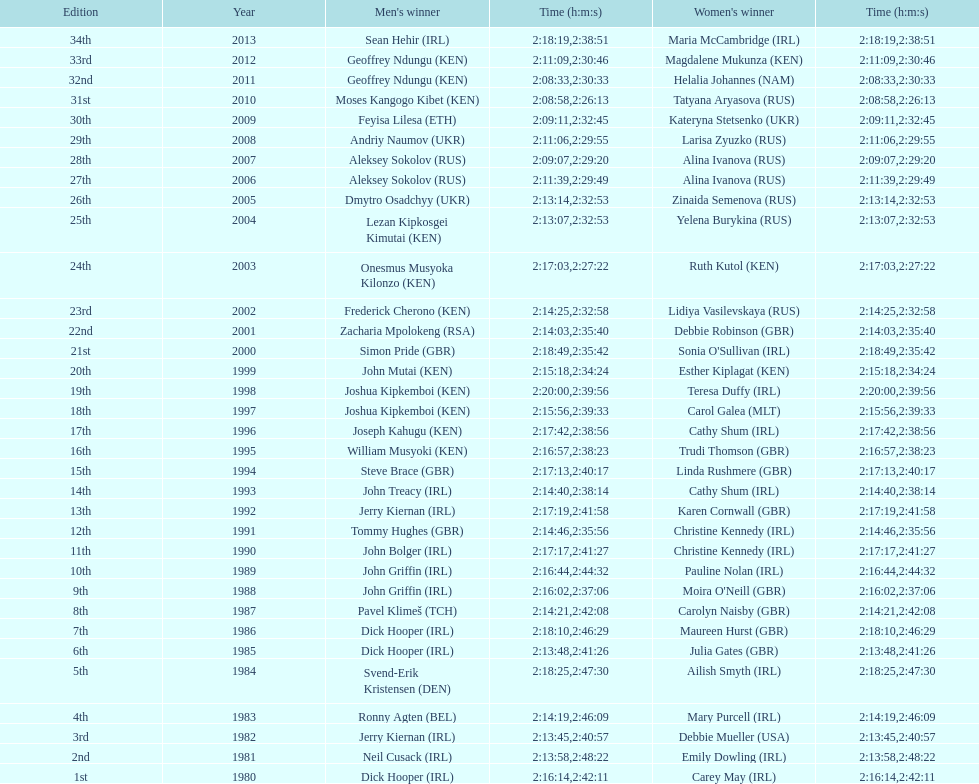Which country is represented for both men and women at the top of the list? Ireland. 